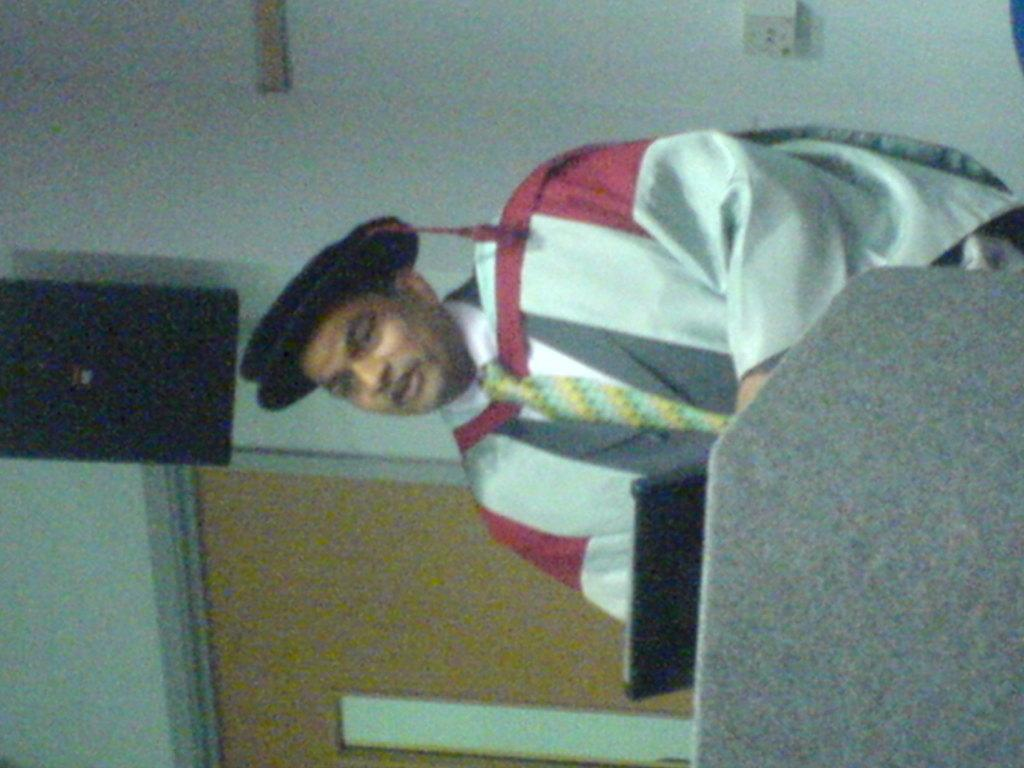What is the person in the image wearing? The person is wearing a graduation dress. What is the person doing in the image? The person is speaking. What object is in front of the person? There is an object in front of the person, but the specific object is not mentioned in the facts. What can be seen in the image that might be used for amplifying sound? There is a speaker in the image. What architectural feature is visible in the image? There is a door in the image. What type of wound can be seen on the person's arm in the image? There is no wound visible on the person's arm in the image. What operation is being performed on the person in the image? There is no operation being performed on the person in the image. 